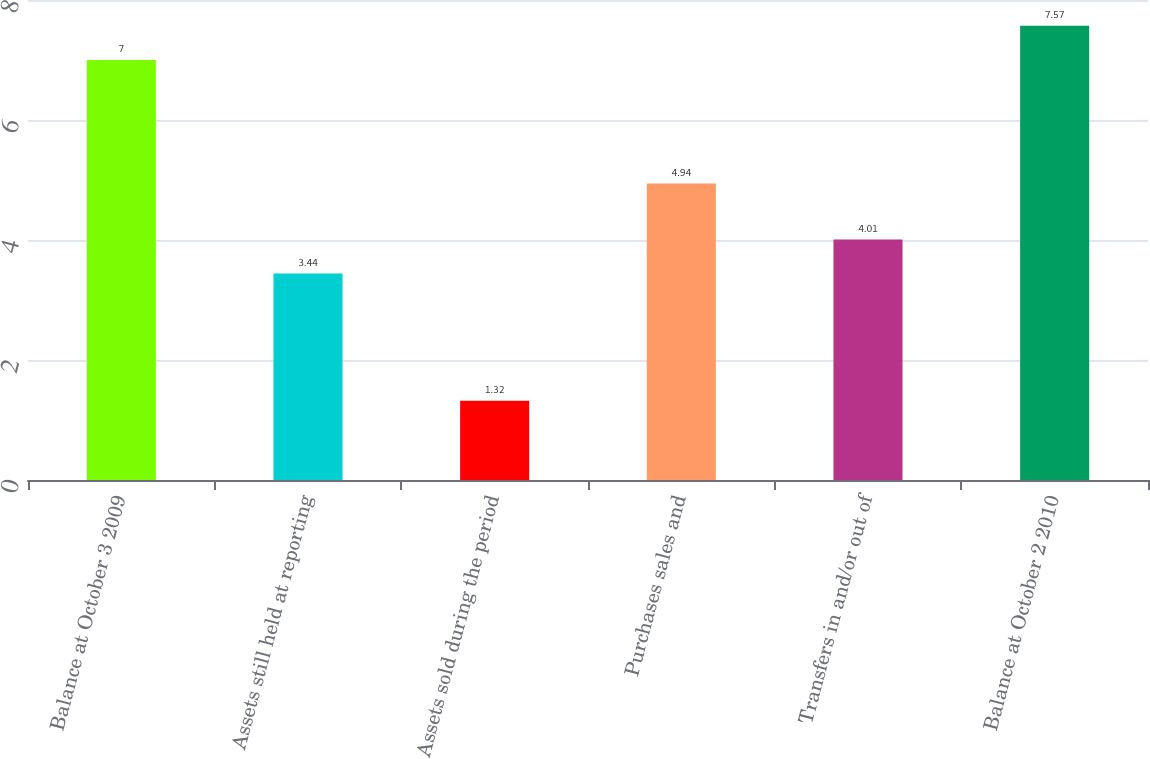Convert chart. <chart><loc_0><loc_0><loc_500><loc_500><bar_chart><fcel>Balance at October 3 2009<fcel>Assets still held at reporting<fcel>Assets sold during the period<fcel>Purchases sales and<fcel>Transfers in and/or out of<fcel>Balance at October 2 2010<nl><fcel>7<fcel>3.44<fcel>1.32<fcel>4.94<fcel>4.01<fcel>7.57<nl></chart> 